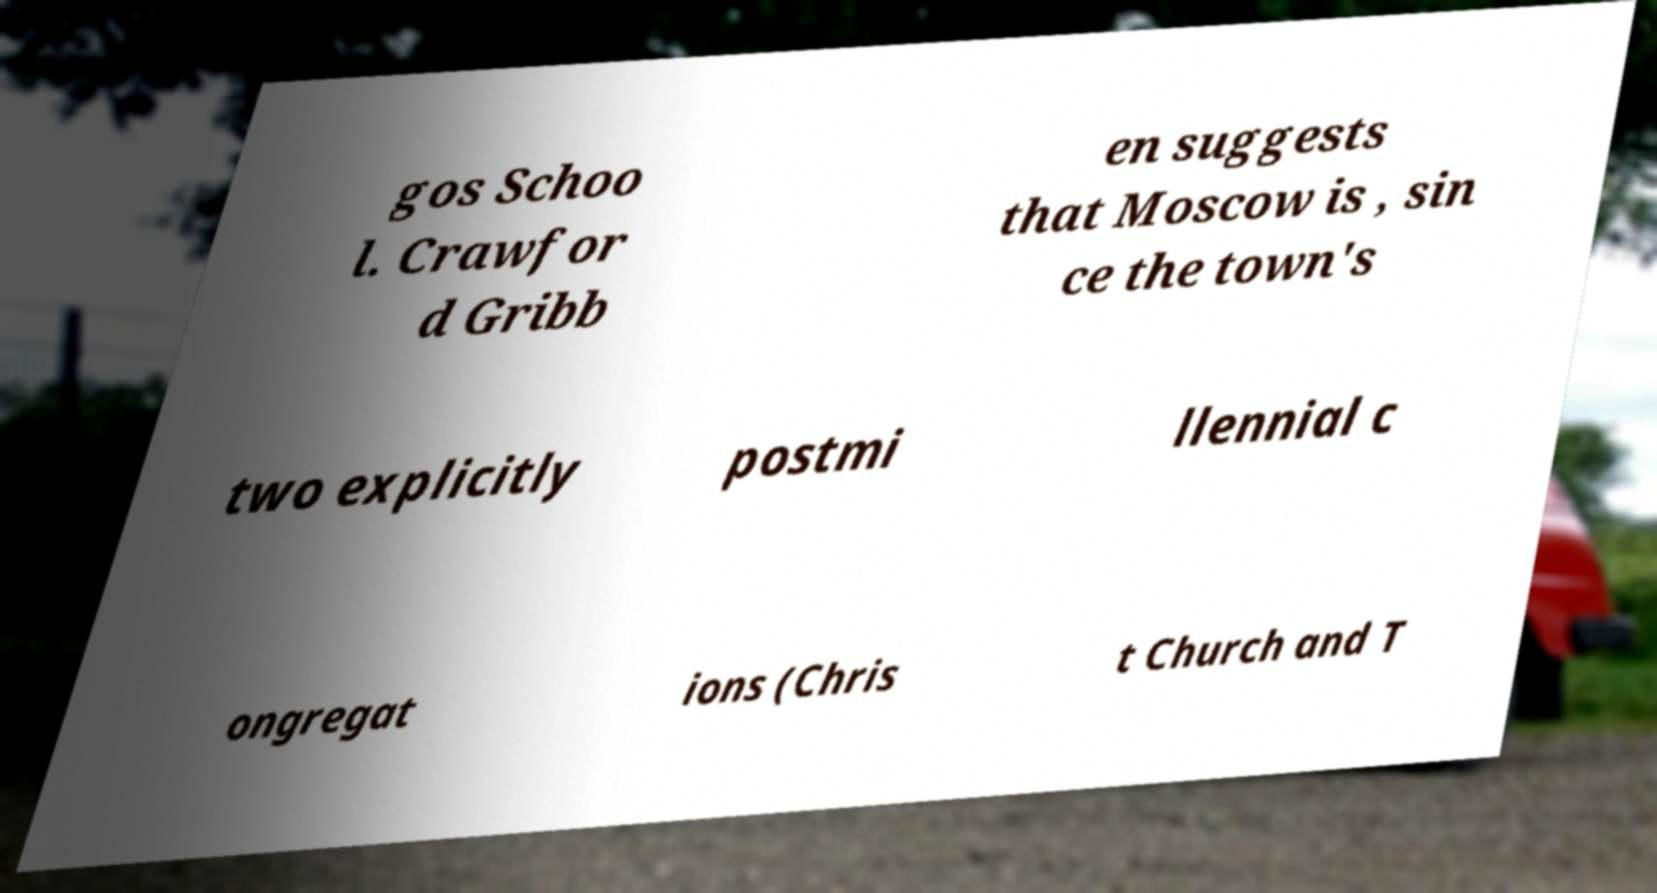Could you assist in decoding the text presented in this image and type it out clearly? gos Schoo l. Crawfor d Gribb en suggests that Moscow is , sin ce the town's two explicitly postmi llennial c ongregat ions (Chris t Church and T 